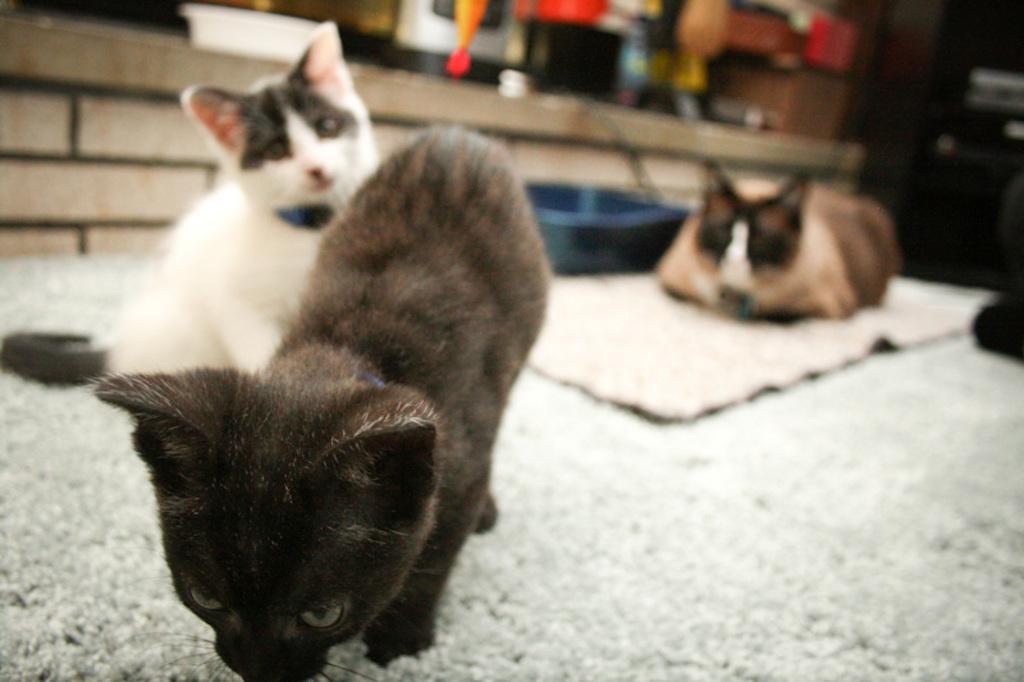In one or two sentences, can you explain what this image depicts? In this image there is a cat in the middle. Behind the cat there is another cat. On the right side there is a dog which is sleeping on the floor. Beside the dog there is a tray. At the bottom there is a mat. 